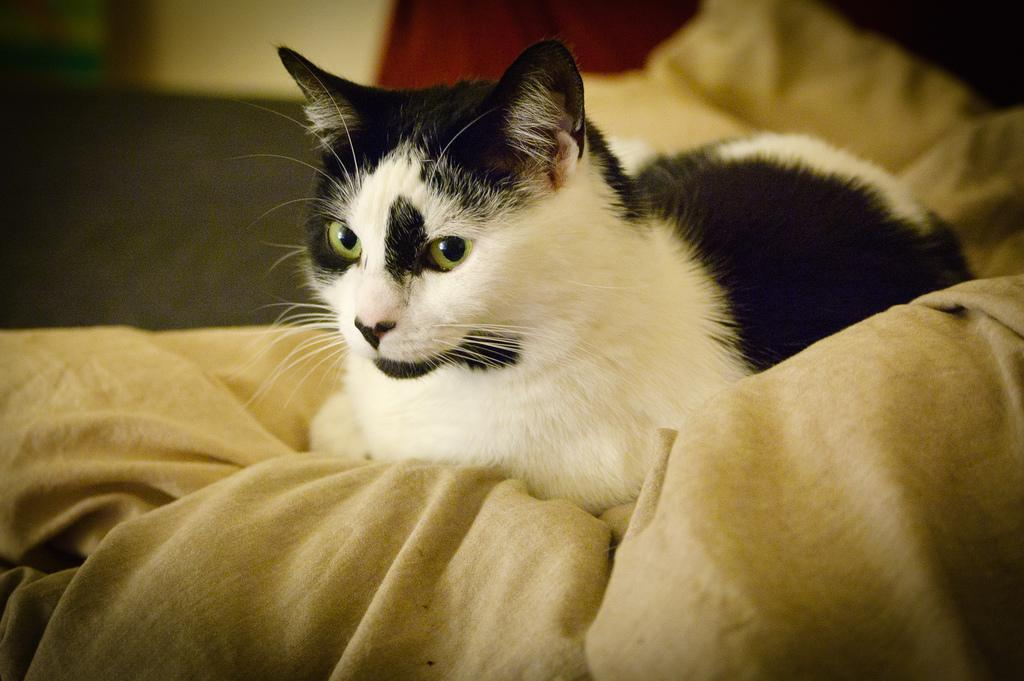What animal is present in the image? There is a cat in the picture. Can you describe the color of the cat? The cat is black and white in color. What is the cat doing in the image? The cat is sitting on a surface. How would you describe the background of the image? The background of the image is blurred. How many straws are visible in the image? There are no straws present in the image. What type of winter clothing is the cat wearing in the image? The cat is not wearing any winter clothing in the image, as it is not dressed. 